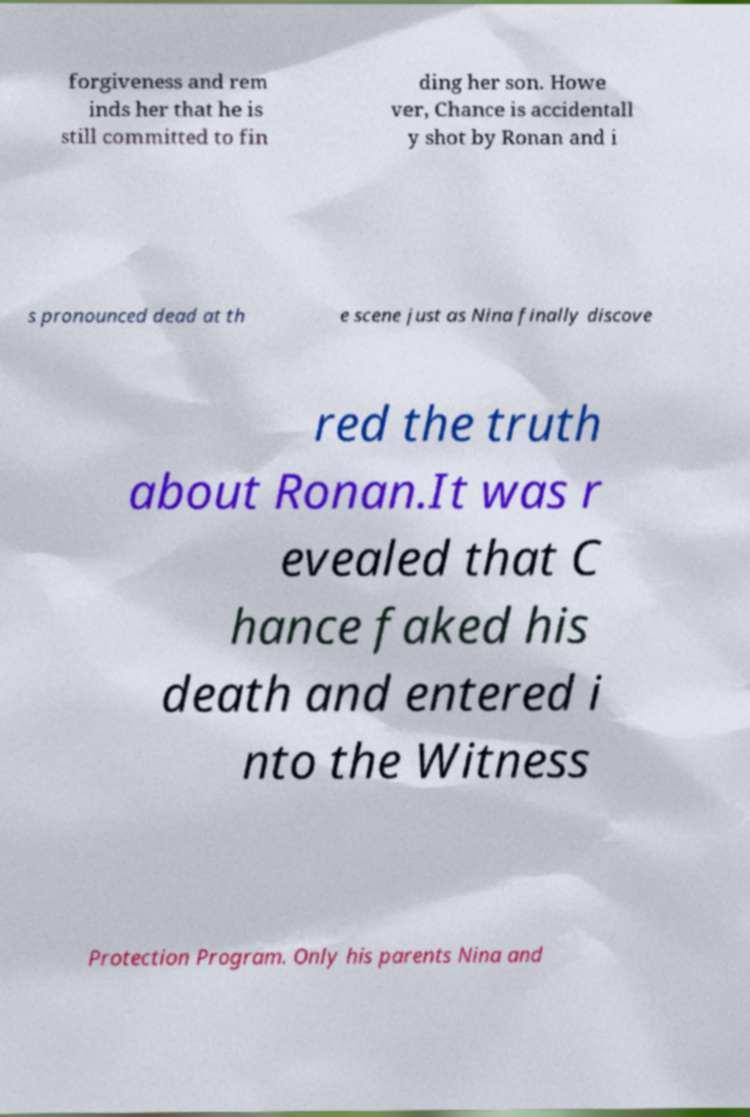I need the written content from this picture converted into text. Can you do that? forgiveness and rem inds her that he is still committed to fin ding her son. Howe ver, Chance is accidentall y shot by Ronan and i s pronounced dead at th e scene just as Nina finally discove red the truth about Ronan.It was r evealed that C hance faked his death and entered i nto the Witness Protection Program. Only his parents Nina and 